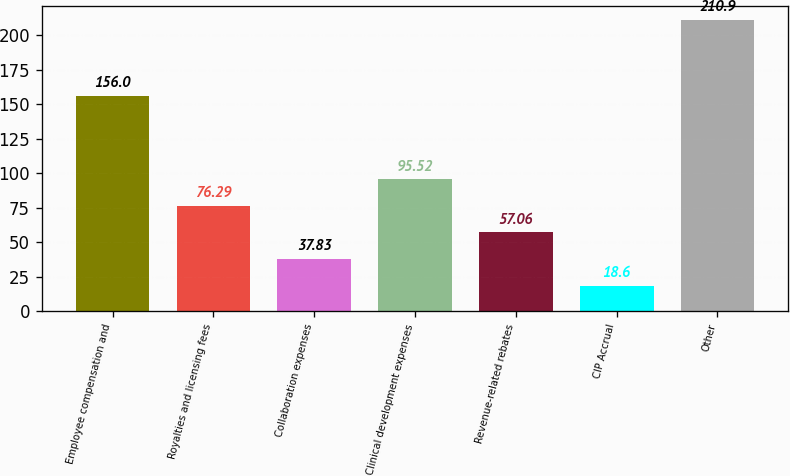<chart> <loc_0><loc_0><loc_500><loc_500><bar_chart><fcel>Employee compensation and<fcel>Royalties and licensing fees<fcel>Collaboration expenses<fcel>Clinical development expenses<fcel>Revenue-related rebates<fcel>CIP Accrual<fcel>Other<nl><fcel>156<fcel>76.29<fcel>37.83<fcel>95.52<fcel>57.06<fcel>18.6<fcel>210.9<nl></chart> 